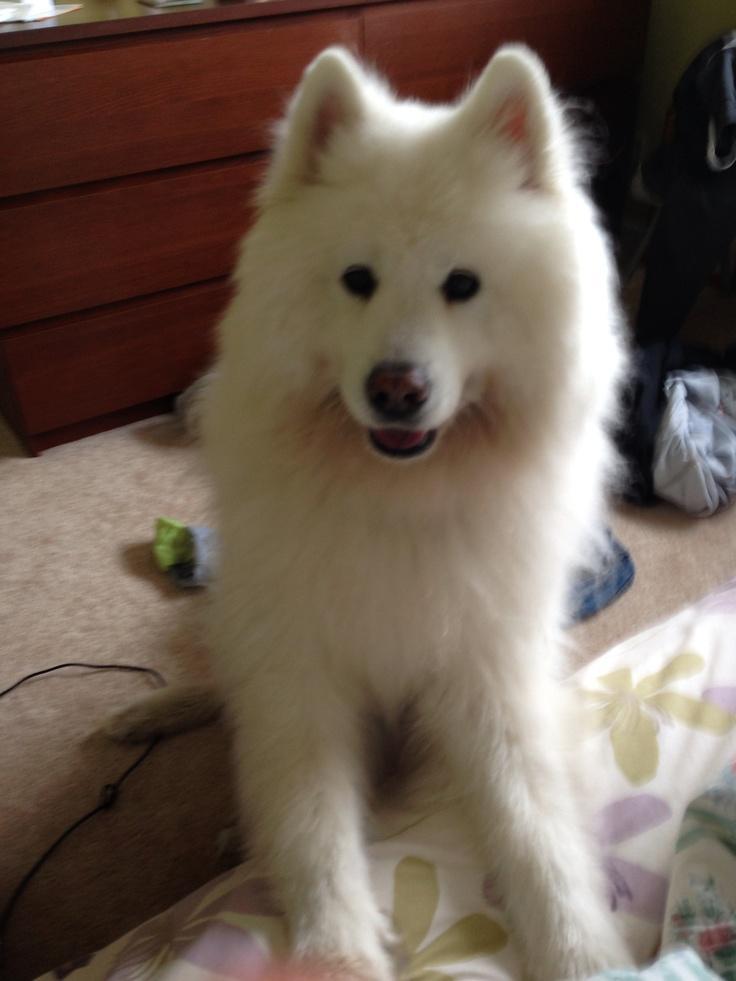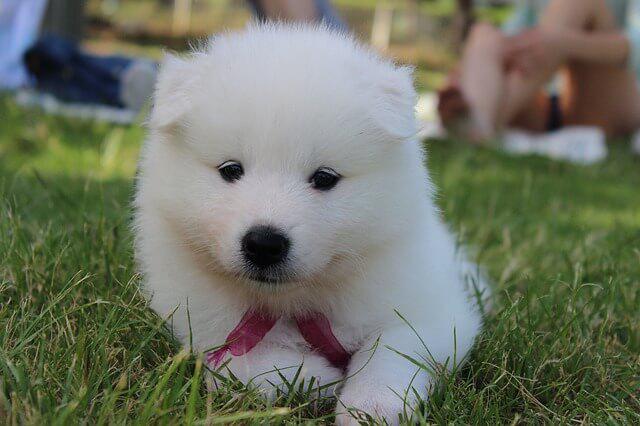The first image is the image on the left, the second image is the image on the right. Given the left and right images, does the statement "One of the images show a single dog standing on all four legs." hold true? Answer yes or no. No. The first image is the image on the left, the second image is the image on the right. Evaluate the accuracy of this statement regarding the images: "One image shows a reclining white dog chewing on something.". Is it true? Answer yes or no. No. 